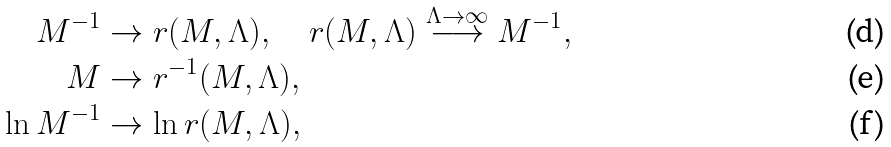Convert formula to latex. <formula><loc_0><loc_0><loc_500><loc_500>M ^ { - 1 } & \to r ( M , \Lambda ) , \quad r ( M , \Lambda ) \stackrel { \Lambda \to \infty } { \longrightarrow } M ^ { - 1 } , \\ M & \to r ^ { - 1 } ( M , \Lambda ) , \\ \ln M ^ { - 1 } & \to \ln r ( M , \Lambda ) ,</formula> 